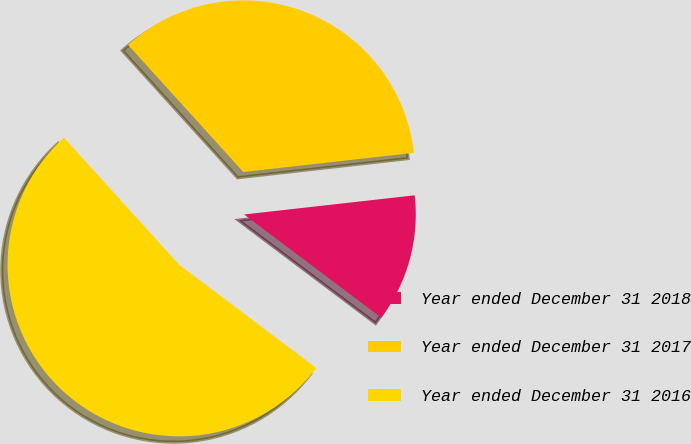Convert chart. <chart><loc_0><loc_0><loc_500><loc_500><pie_chart><fcel>Year ended December 31 2018<fcel>Year ended December 31 2017<fcel>Year ended December 31 2016<nl><fcel>12.05%<fcel>34.94%<fcel>53.01%<nl></chart> 